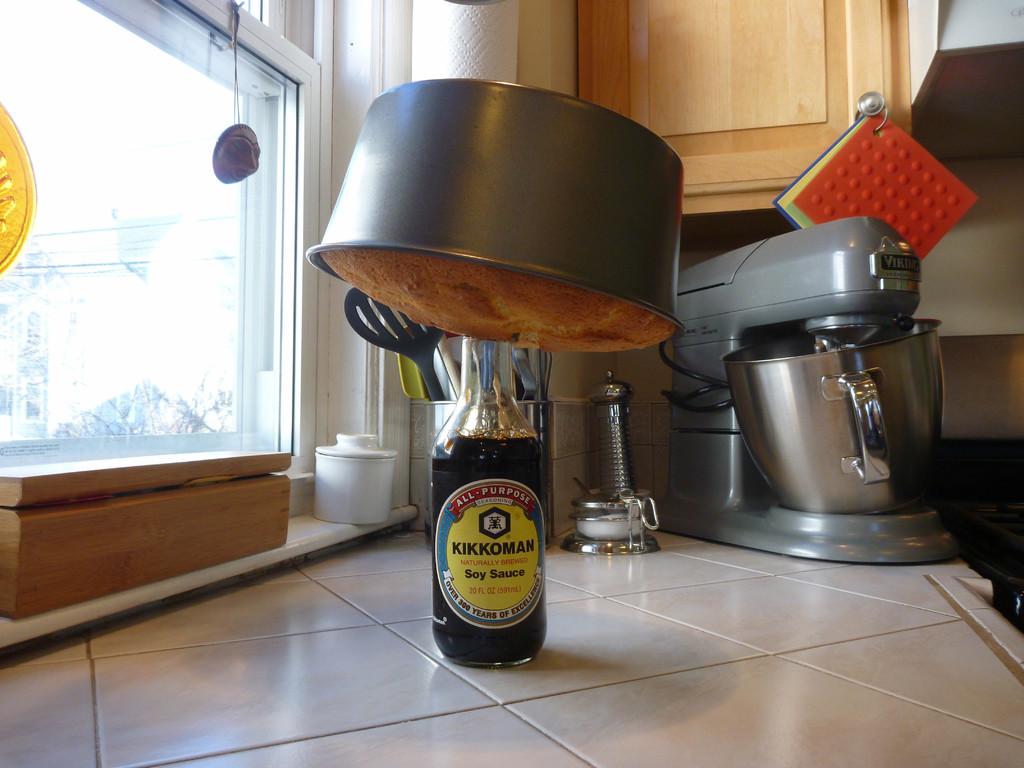What is the liquid in the bottle?
Ensure brevity in your answer.  Soy sauce. What brand of soy sauce is this?
Provide a succinct answer. Kikkoman. 